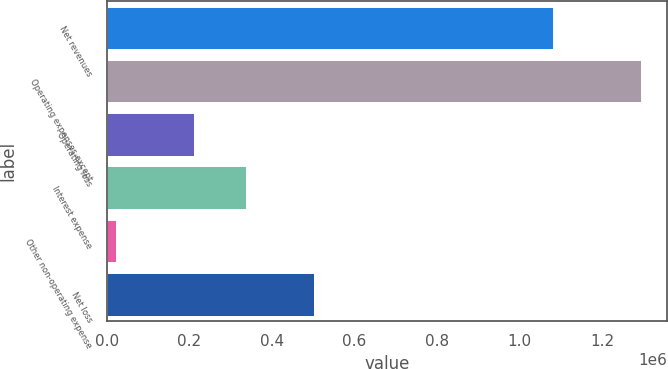Convert chart to OTSL. <chart><loc_0><loc_0><loc_500><loc_500><bar_chart><fcel>Net revenues<fcel>Operating expenses except<fcel>Operating loss<fcel>Interest expense<fcel>Other non-operating expense<fcel>Net loss<nl><fcel>1.08186e+06<fcel>1.29349e+06<fcel>211632<fcel>338711<fcel>22706<fcel>502174<nl></chart> 